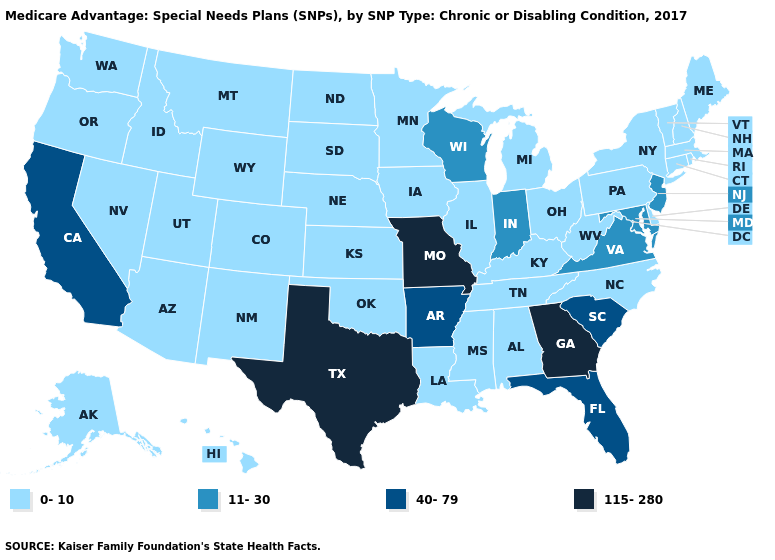How many symbols are there in the legend?
Keep it brief. 4. Which states have the lowest value in the USA?
Quick response, please. Alaska, Alabama, Arizona, Colorado, Connecticut, Delaware, Hawaii, Iowa, Idaho, Illinois, Kansas, Kentucky, Louisiana, Massachusetts, Maine, Michigan, Minnesota, Mississippi, Montana, North Carolina, North Dakota, Nebraska, New Hampshire, New Mexico, Nevada, New York, Ohio, Oklahoma, Oregon, Pennsylvania, Rhode Island, South Dakota, Tennessee, Utah, Vermont, Washington, West Virginia, Wyoming. What is the value of Maine?
Short answer required. 0-10. Name the states that have a value in the range 0-10?
Quick response, please. Alaska, Alabama, Arizona, Colorado, Connecticut, Delaware, Hawaii, Iowa, Idaho, Illinois, Kansas, Kentucky, Louisiana, Massachusetts, Maine, Michigan, Minnesota, Mississippi, Montana, North Carolina, North Dakota, Nebraska, New Hampshire, New Mexico, Nevada, New York, Ohio, Oklahoma, Oregon, Pennsylvania, Rhode Island, South Dakota, Tennessee, Utah, Vermont, Washington, West Virginia, Wyoming. Does Texas have the lowest value in the South?
Quick response, please. No. Name the states that have a value in the range 11-30?
Concise answer only. Indiana, Maryland, New Jersey, Virginia, Wisconsin. Does Missouri have the highest value in the MidWest?
Quick response, please. Yes. Which states have the lowest value in the USA?
Short answer required. Alaska, Alabama, Arizona, Colorado, Connecticut, Delaware, Hawaii, Iowa, Idaho, Illinois, Kansas, Kentucky, Louisiana, Massachusetts, Maine, Michigan, Minnesota, Mississippi, Montana, North Carolina, North Dakota, Nebraska, New Hampshire, New Mexico, Nevada, New York, Ohio, Oklahoma, Oregon, Pennsylvania, Rhode Island, South Dakota, Tennessee, Utah, Vermont, Washington, West Virginia, Wyoming. Among the states that border Illinois , does Missouri have the lowest value?
Keep it brief. No. Name the states that have a value in the range 0-10?
Answer briefly. Alaska, Alabama, Arizona, Colorado, Connecticut, Delaware, Hawaii, Iowa, Idaho, Illinois, Kansas, Kentucky, Louisiana, Massachusetts, Maine, Michigan, Minnesota, Mississippi, Montana, North Carolina, North Dakota, Nebraska, New Hampshire, New Mexico, Nevada, New York, Ohio, Oklahoma, Oregon, Pennsylvania, Rhode Island, South Dakota, Tennessee, Utah, Vermont, Washington, West Virginia, Wyoming. Which states have the highest value in the USA?
Write a very short answer. Georgia, Missouri, Texas. How many symbols are there in the legend?
Write a very short answer. 4. Name the states that have a value in the range 115-280?
Quick response, please. Georgia, Missouri, Texas. Among the states that border Georgia , which have the lowest value?
Quick response, please. Alabama, North Carolina, Tennessee. Name the states that have a value in the range 11-30?
Keep it brief. Indiana, Maryland, New Jersey, Virginia, Wisconsin. 